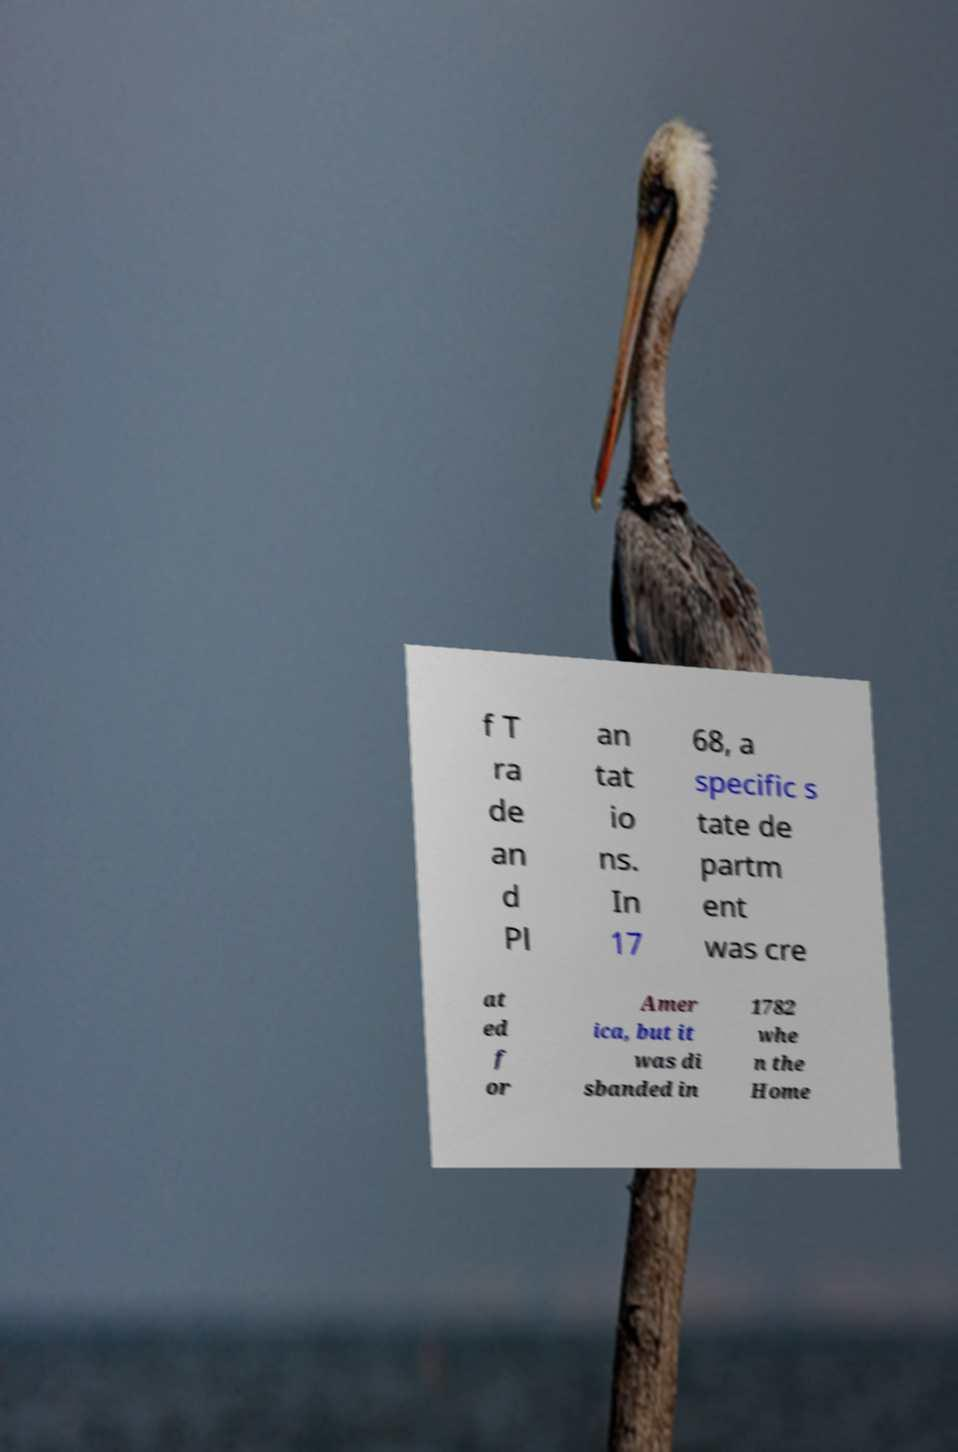Please identify and transcribe the text found in this image. f T ra de an d Pl an tat io ns. In 17 68, a specific s tate de partm ent was cre at ed f or Amer ica, but it was di sbanded in 1782 whe n the Home 